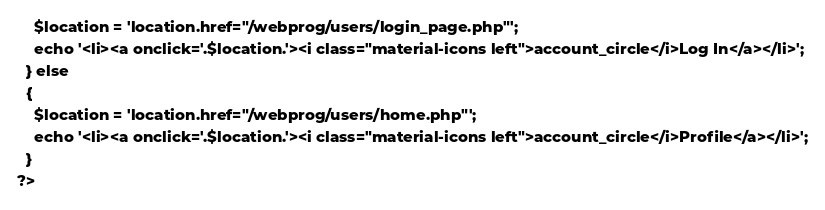<code> <loc_0><loc_0><loc_500><loc_500><_PHP_>    $location = 'location.href="/webprog/users/login_page.php"';
    echo '<li><a onclick='.$location.'><i class="material-icons left">account_circle</i>Log In</a></li>';
  } else
  {
    $location = 'location.href="/webprog/users/home.php"';
    echo '<li><a onclick='.$location.'><i class="material-icons left">account_circle</i>Profile</a></li>';
  }
?>
</code> 